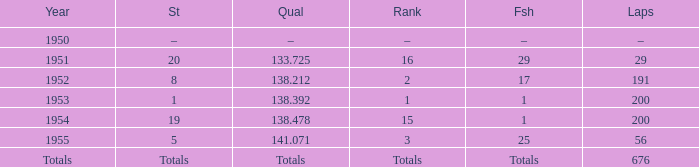What year was the ranking 1? 1953.0. 